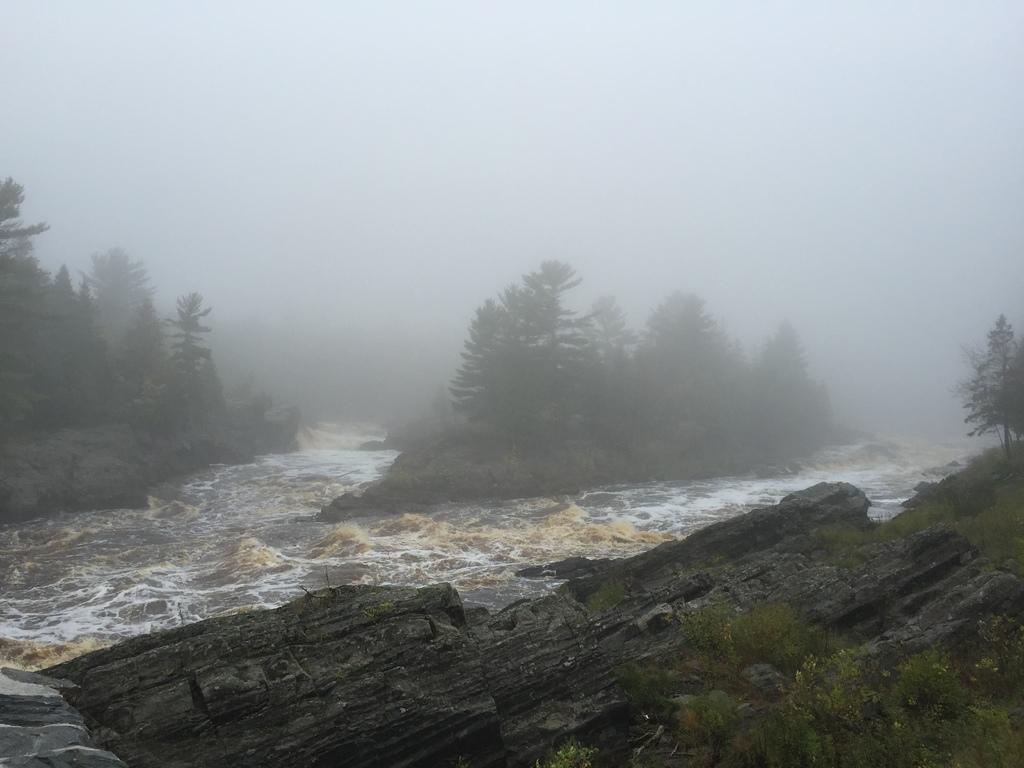How would you summarize this image in a sentence or two? In this image we can see water, rocks, plants, and trees. In the background there is sky. 